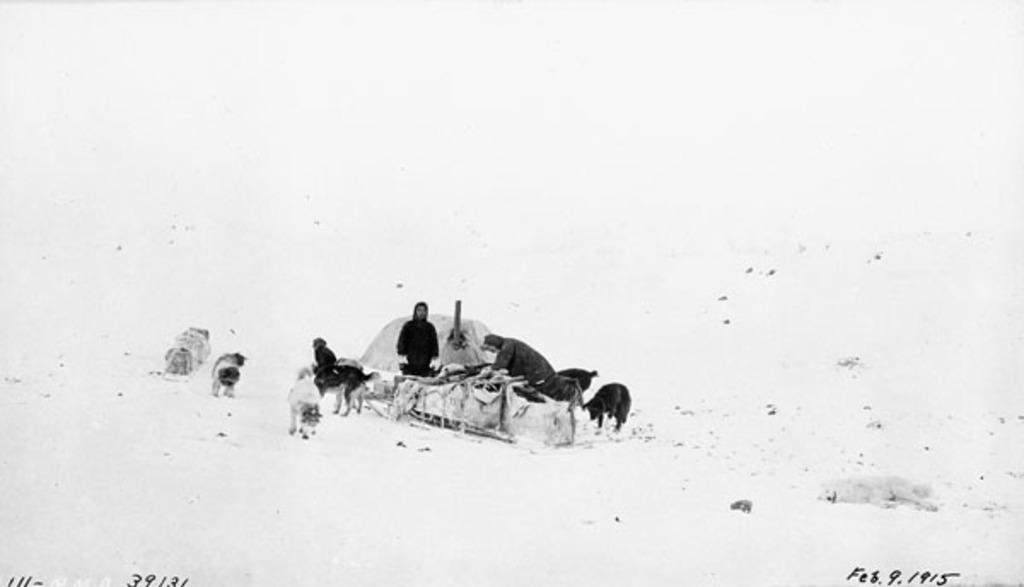What is the color scheme of the image? The image is black and white. What types of living beings are present in the image? There are animals and people in the image. What is the ground made of in the image? The ground is made of snow, as there are objects on the snow. What can be found at the bottom of the image? Text is written at the bottom of the image. What type of whip can be seen cracking in the image? There is no whip present in the image. What kind of destruction can be observed in the image? There is no destruction depicted in the image. 